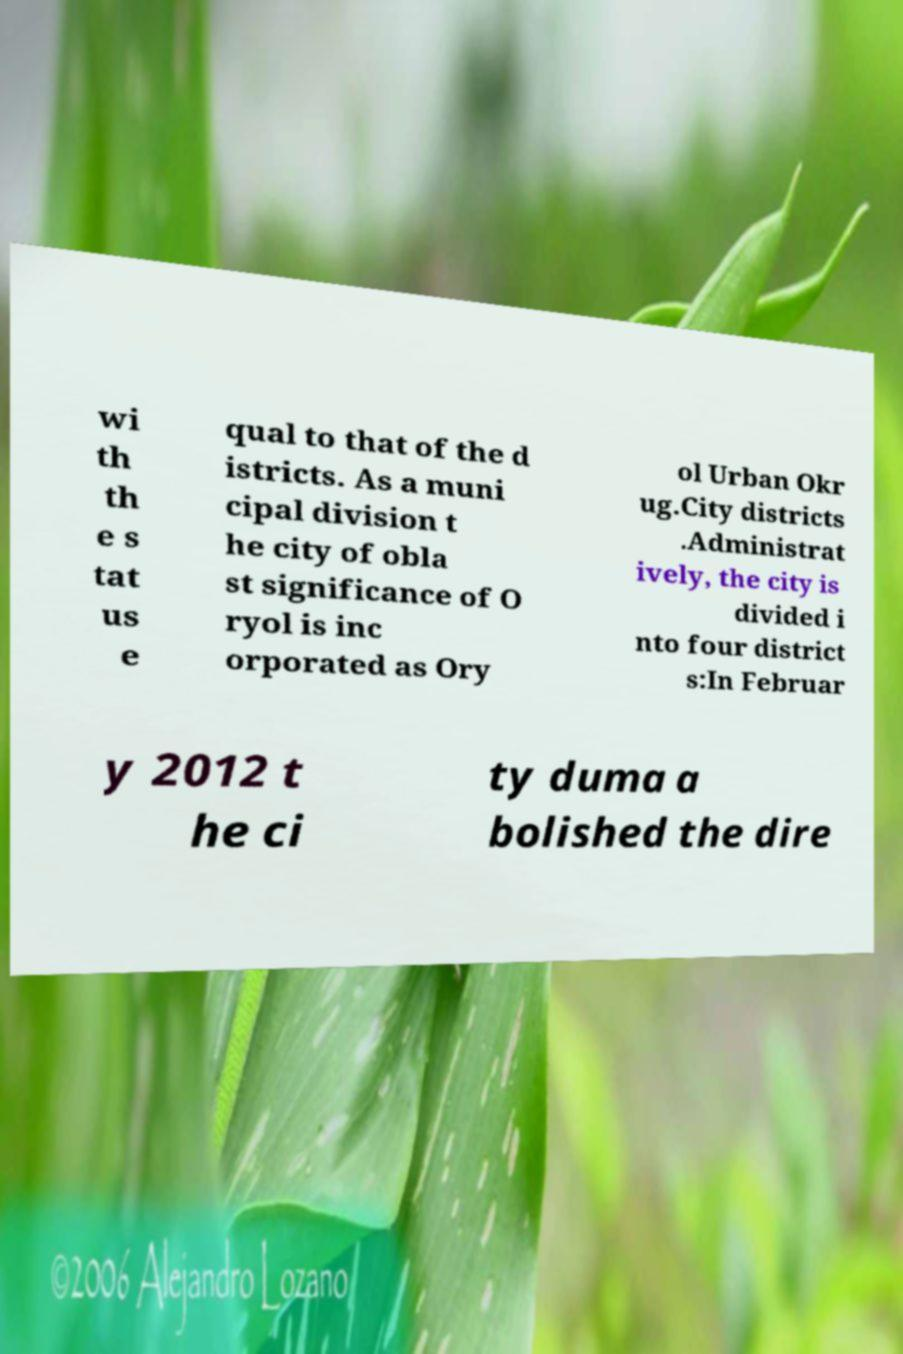Please identify and transcribe the text found in this image. wi th th e s tat us e qual to that of the d istricts. As a muni cipal division t he city of obla st significance of O ryol is inc orporated as Ory ol Urban Okr ug.City districts .Administrat ively, the city is divided i nto four district s:In Februar y 2012 t he ci ty duma a bolished the dire 